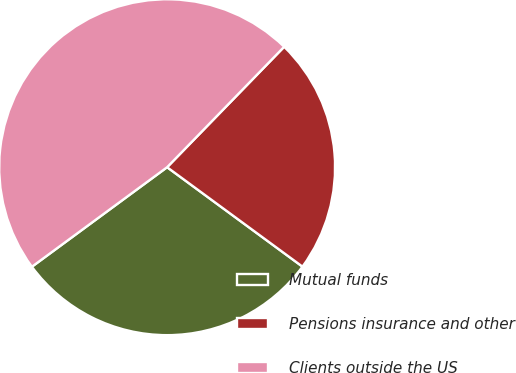Convert chart. <chart><loc_0><loc_0><loc_500><loc_500><pie_chart><fcel>Mutual funds<fcel>Pensions insurance and other<fcel>Clients outside the US<nl><fcel>29.82%<fcel>22.81%<fcel>47.37%<nl></chart> 